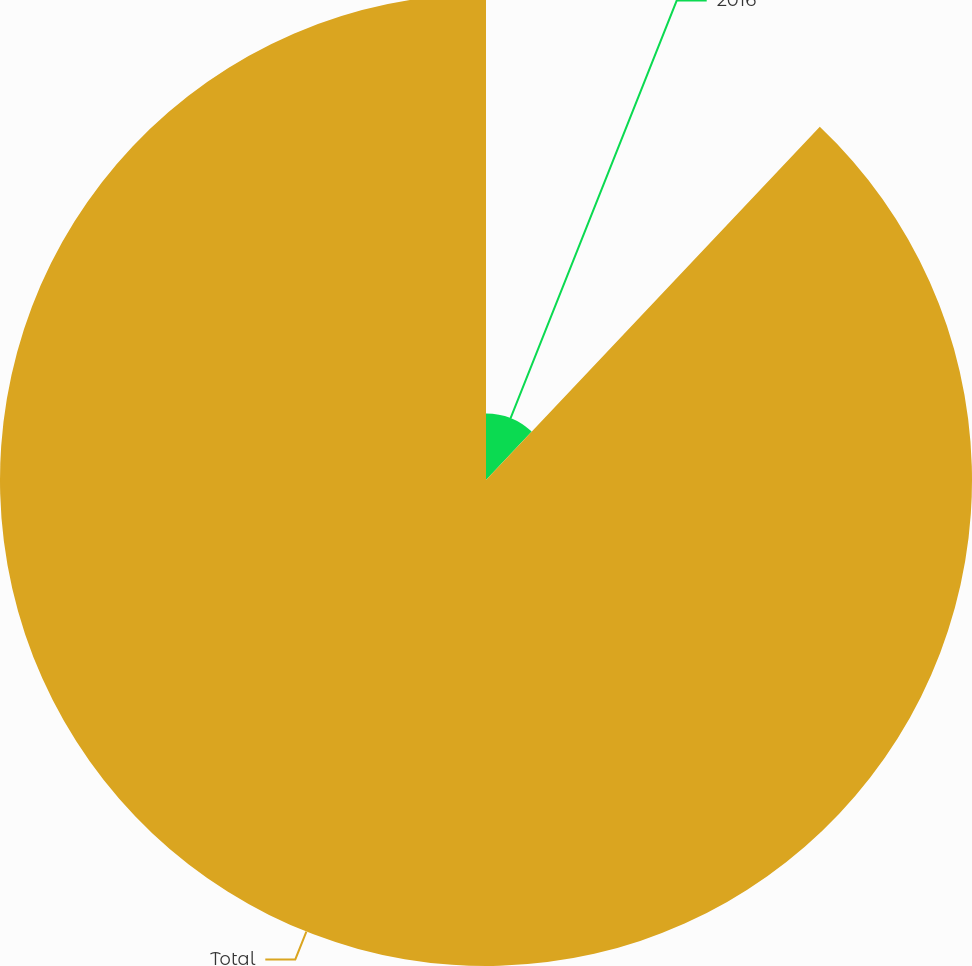Convert chart to OTSL. <chart><loc_0><loc_0><loc_500><loc_500><pie_chart><fcel>2016<fcel>Total<nl><fcel>12.05%<fcel>87.95%<nl></chart> 